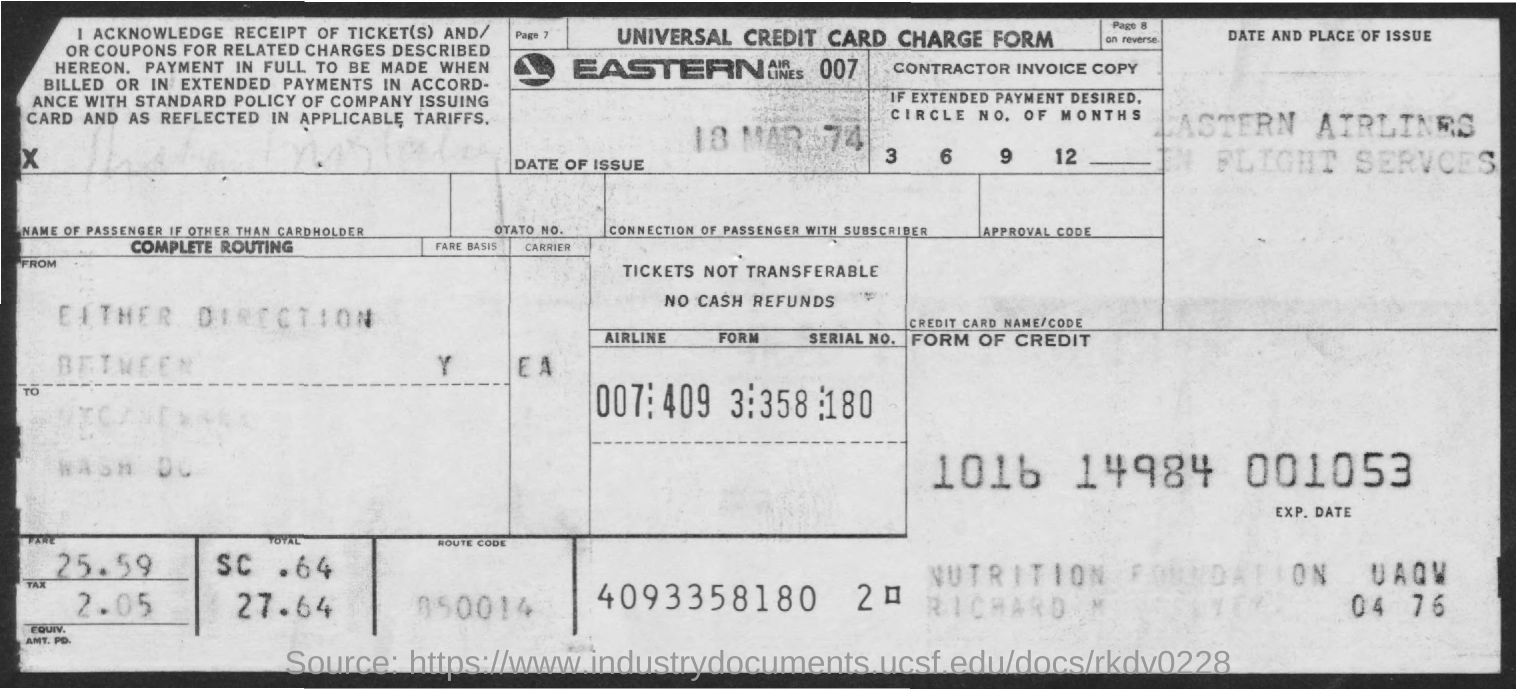List a handful of essential elements in this visual. What is the name of the form given? It is called the Universal Credit Card Charge Form. The total fare, including tax, is 27.64. The name of the airline is Easter Airlines, which is featured on the stamp. The date of issue is March 18, 1974. 